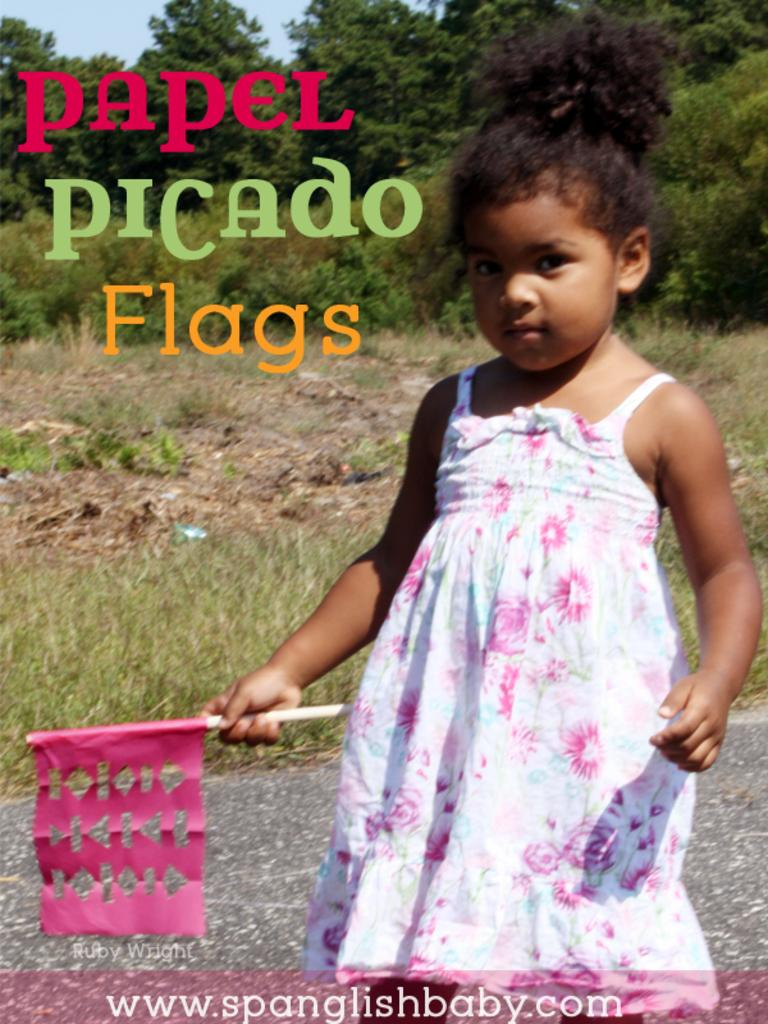What is the main subject of the image? There is a girl standing in the image. What is the girl wearing? The girl is wearing clothes. What is the girl holding in her hand? The girl is holding a flag in her hand. What can be seen in the background of the image? There is a road, grass, trees, and a pale blue sky visible in the image. What else is present in the image? There is a watermark and text in the image. Can you tell me how many cows are grazing in the grass in the image? There are no cows present in the image; it features a girl holding a flag and a background with grass, trees, and a pale blue sky. What type of boot is the queen wearing in the image? There is no queen or boot present in the image. 